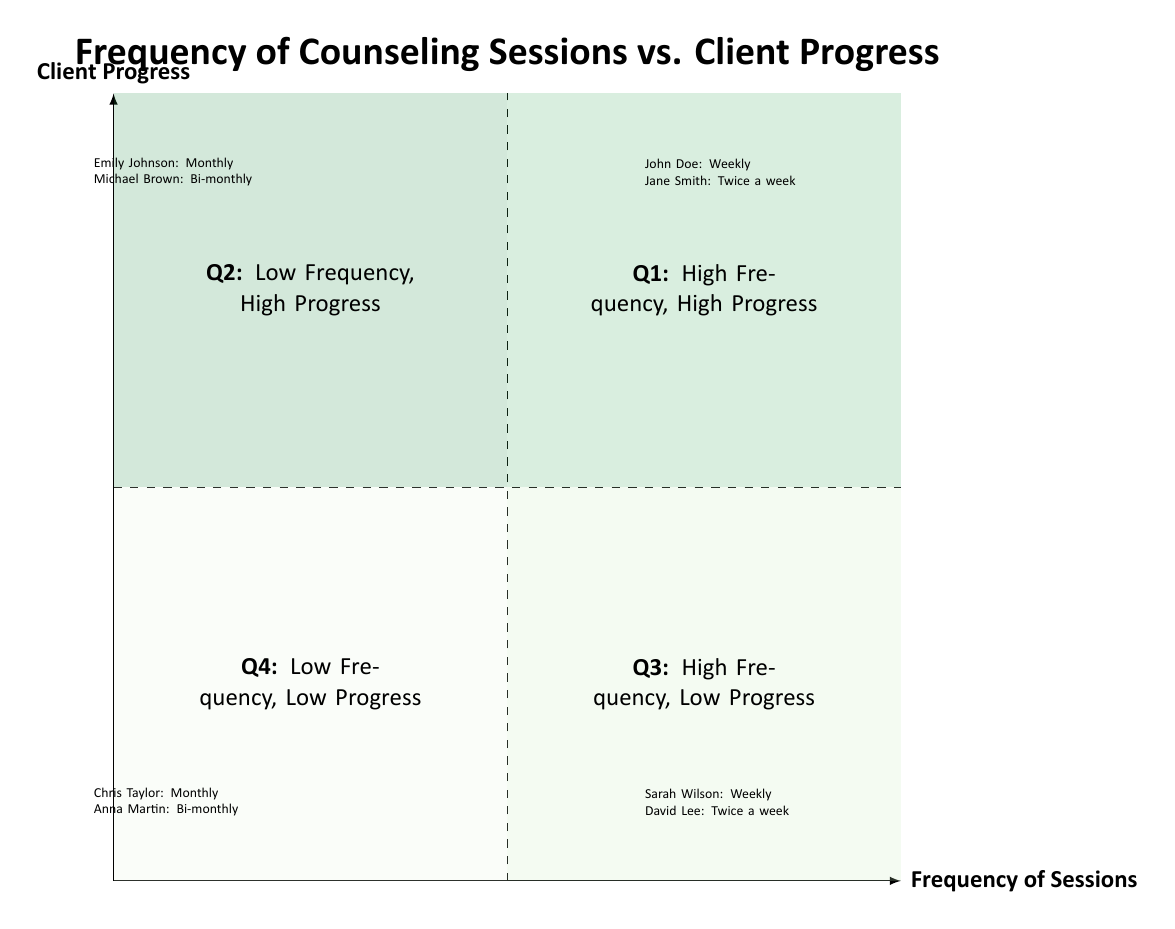What is the client name in Q1 with the highest session frequency? In Q1, the clients listed are John Doe and Jane Smith. Among these, Jane Smith has the highest session frequency listed as "Twice a week," while John Doe's frequency is "Weekly."
Answer: Jane Smith How many clients are listed in Q3? In Q3, there are two clients mentioned: Sarah Wilson and David Lee. Therefore, we count them, resulting in a total of two clients in this quadrant.
Answer: 2 Which quadrant contains clients with low frequency yet high progress? The quadrant that describes low frequency and high progress is Q2. In this quadrant, the clients Emily Johnson and Michael Brown are represented.
Answer: Q2 What is the session frequency of David Lee? David Lee's session frequency is presented as "Twice a week," making this a direct reference to the information given about him in Q3.
Answer: Twice a week In which quadrant would you classify Chris Taylor? Chris Taylor is listed in Q4 with "Monthly" session frequency and "Slight improvements in mood, sporadic participation." This places him in the quadrant for low frequency and low progress.
Answer: Q4 What type of progress does Jane Smith report? Jane Smith reports a "Significant reduction in depressive episodes, improved emotional regulation" as her progress metrics. This detail is clearly stated under her information in Q1.
Answer: Significant reduction in depressive episodes Which client has bi-monthly sessions in Q2? In Q2, Michael Brown is noted to have "Bi-monthly" sessions, which directly identifies him as the corresponding client with this frequency.
Answer: Michael Brown How many clients in Q4 have bi-monthly sessions? There are two clients in Q4: Chris Taylor and Anna Martin. Among these, only Anna Martin reports having "Bi-monthly" sessions, which we count.
Answer: 1 